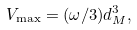<formula> <loc_0><loc_0><loc_500><loc_500>V _ { \max } = ( \omega / 3 ) d _ { M } ^ { 3 } ,</formula> 